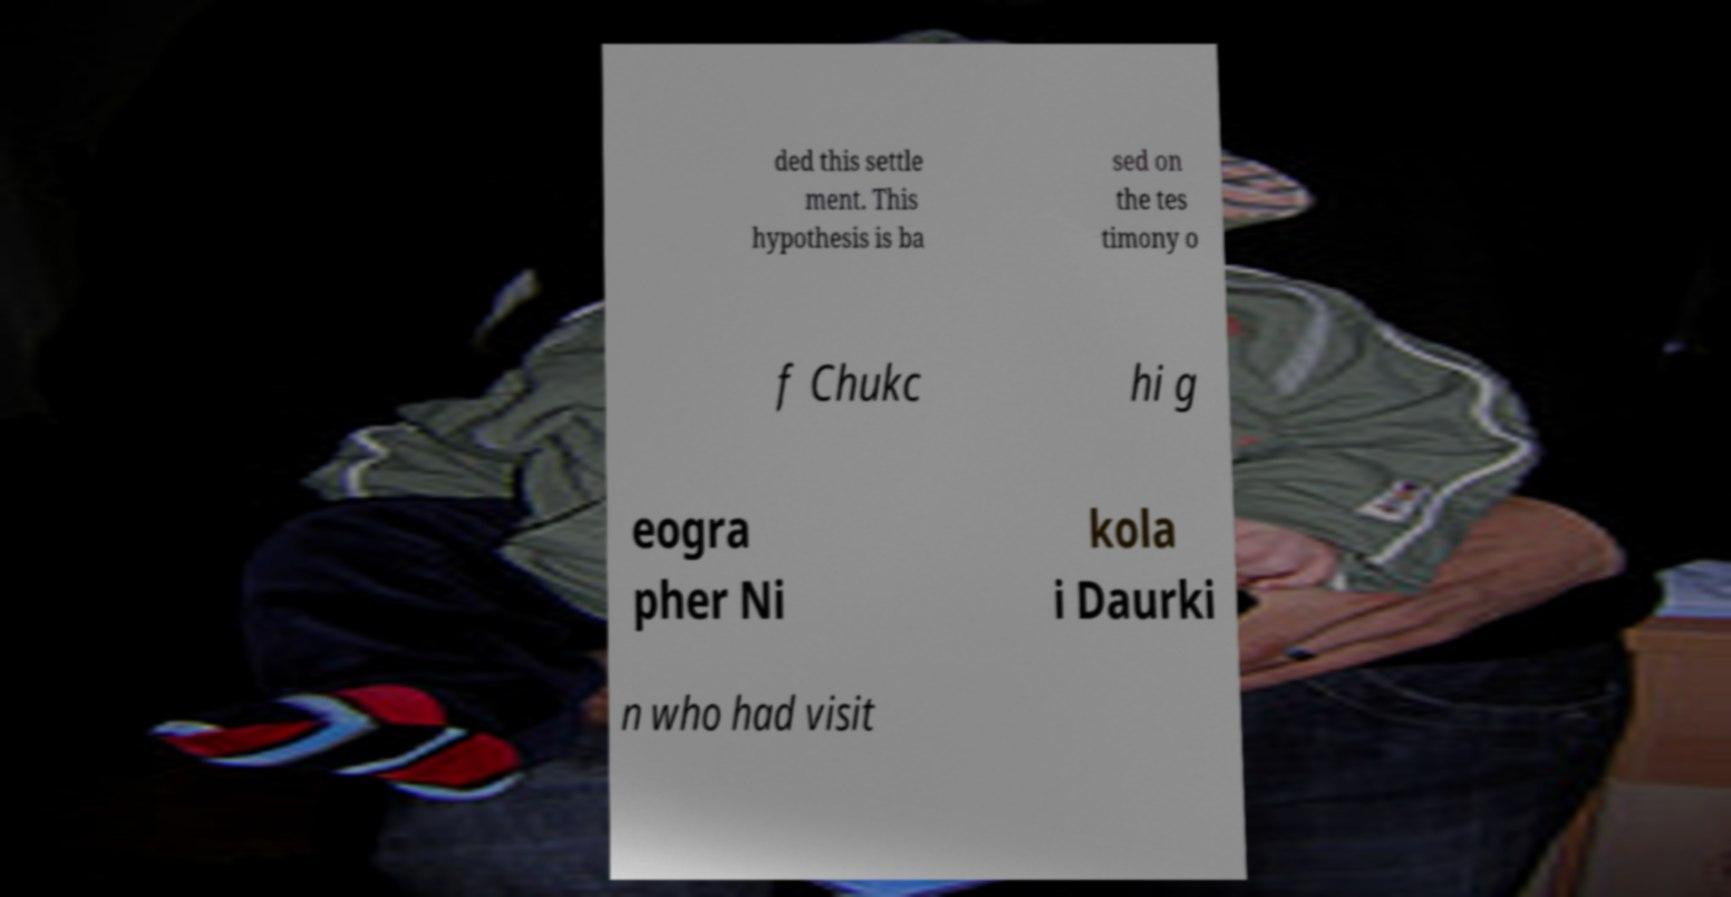Can you read and provide the text displayed in the image?This photo seems to have some interesting text. Can you extract and type it out for me? ded this settle ment. This hypothesis is ba sed on the tes timony o f Chukc hi g eogra pher Ni kola i Daurki n who had visit 